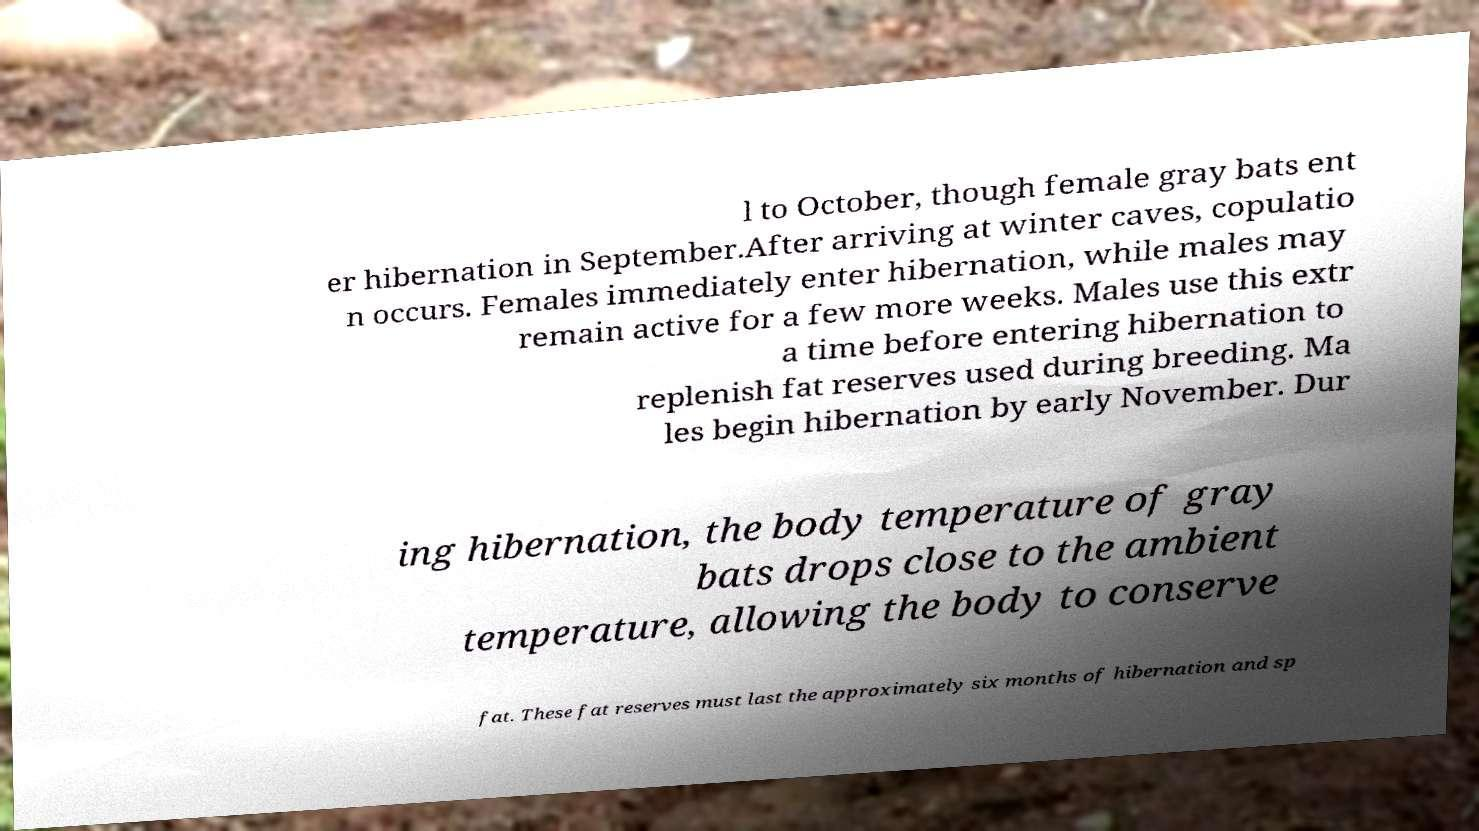Could you extract and type out the text from this image? l to October, though female gray bats ent er hibernation in September.After arriving at winter caves, copulatio n occurs. Females immediately enter hibernation, while males may remain active for a few more weeks. Males use this extr a time before entering hibernation to replenish fat reserves used during breeding. Ma les begin hibernation by early November. Dur ing hibernation, the body temperature of gray bats drops close to the ambient temperature, allowing the body to conserve fat. These fat reserves must last the approximately six months of hibernation and sp 